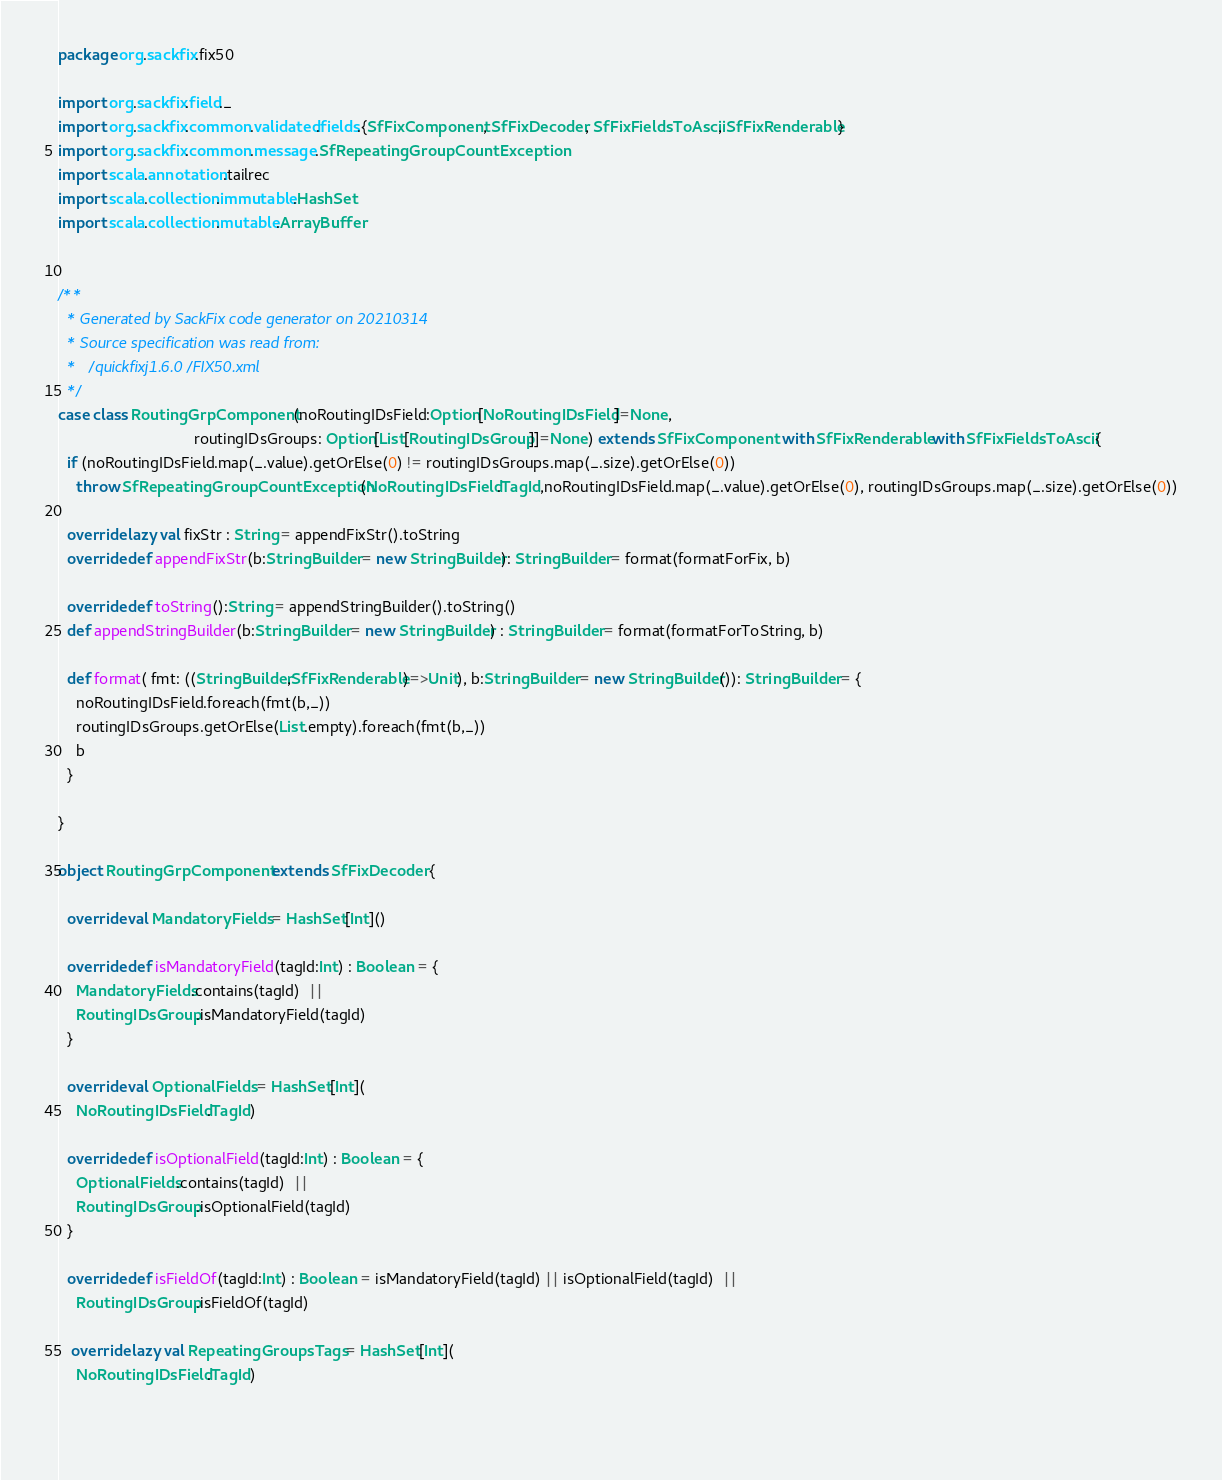<code> <loc_0><loc_0><loc_500><loc_500><_Scala_>package org.sackfix.fix50

import org.sackfix.field._
import org.sackfix.common.validated.fields.{SfFixComponent, SfFixDecoder, SfFixFieldsToAscii, SfFixRenderable}
import org.sackfix.common.message.SfRepeatingGroupCountException
import scala.annotation.tailrec
import scala.collection.immutable.HashSet
import scala.collection.mutable.ArrayBuffer


/**
  * Generated by SackFix code generator on 20210314
  * Source specification was read from:
  *   /quickfixj1.6.0/FIX50.xml
  */
case class RoutingGrpComponent(noRoutingIDsField:Option[NoRoutingIDsField]=None,
                               routingIDsGroups: Option[List[RoutingIDsGroup]]=None) extends SfFixComponent  with SfFixRenderable with SfFixFieldsToAscii {
  if (noRoutingIDsField.map(_.value).getOrElse(0) != routingIDsGroups.map(_.size).getOrElse(0))
    throw SfRepeatingGroupCountException(NoRoutingIDsField.TagId,noRoutingIDsField.map(_.value).getOrElse(0), routingIDsGroups.map(_.size).getOrElse(0))

  override lazy val fixStr : String = appendFixStr().toString
  override def appendFixStr(b:StringBuilder = new StringBuilder): StringBuilder = format(formatForFix, b)

  override def toString():String = appendStringBuilder().toString()
  def appendStringBuilder(b:StringBuilder = new StringBuilder) : StringBuilder = format(formatForToString, b)

  def format( fmt: ((StringBuilder,SfFixRenderable)=>Unit), b:StringBuilder = new StringBuilder()): StringBuilder = {
    noRoutingIDsField.foreach(fmt(b,_))
    routingIDsGroups.getOrElse(List.empty).foreach(fmt(b,_))
    b
  }

}
     
object RoutingGrpComponent extends SfFixDecoder {

  override val MandatoryFields = HashSet[Int]()

  override def isMandatoryField(tagId:Int) : Boolean = {
    MandatoryFields.contains(tagId)  || 
    RoutingIDsGroup.isMandatoryField(tagId)
  }

  override val OptionalFields = HashSet[Int](
    NoRoutingIDsField.TagId)

  override def isOptionalField(tagId:Int) : Boolean = {
    OptionalFields.contains(tagId)  || 
    RoutingIDsGroup.isOptionalField(tagId)
  }

  override def isFieldOf(tagId:Int) : Boolean = isMandatoryField(tagId) || isOptionalField(tagId)  || 
    RoutingIDsGroup.isFieldOf(tagId)

   override lazy val RepeatingGroupsTags = HashSet[Int](
    NoRoutingIDsField.TagId)
  
      </code> 